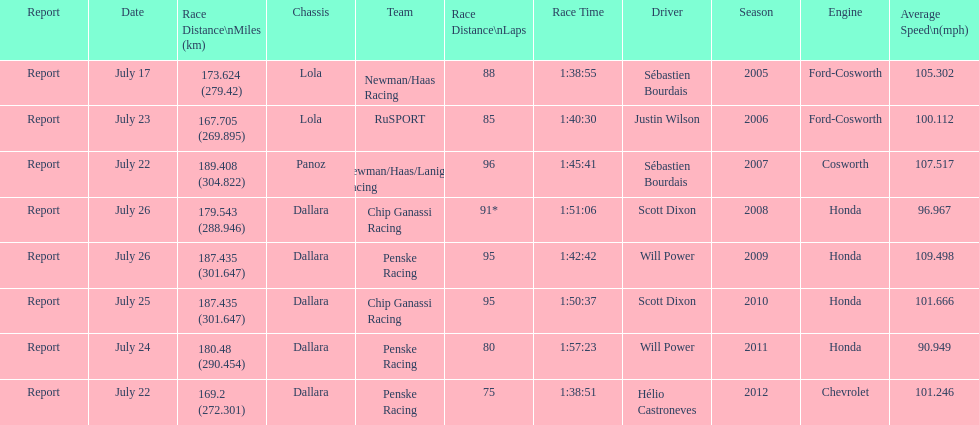How many total honda engines were there? 4. 